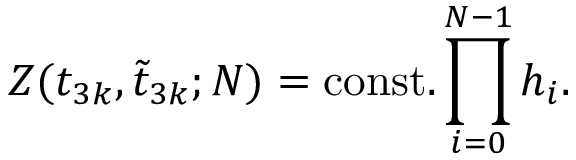<formula> <loc_0><loc_0><loc_500><loc_500>Z ( t _ { 3 k } , \tilde { t } _ { 3 k } ; N ) = c o n s t . \prod _ { i = 0 } ^ { N - 1 } h _ { i } .</formula> 